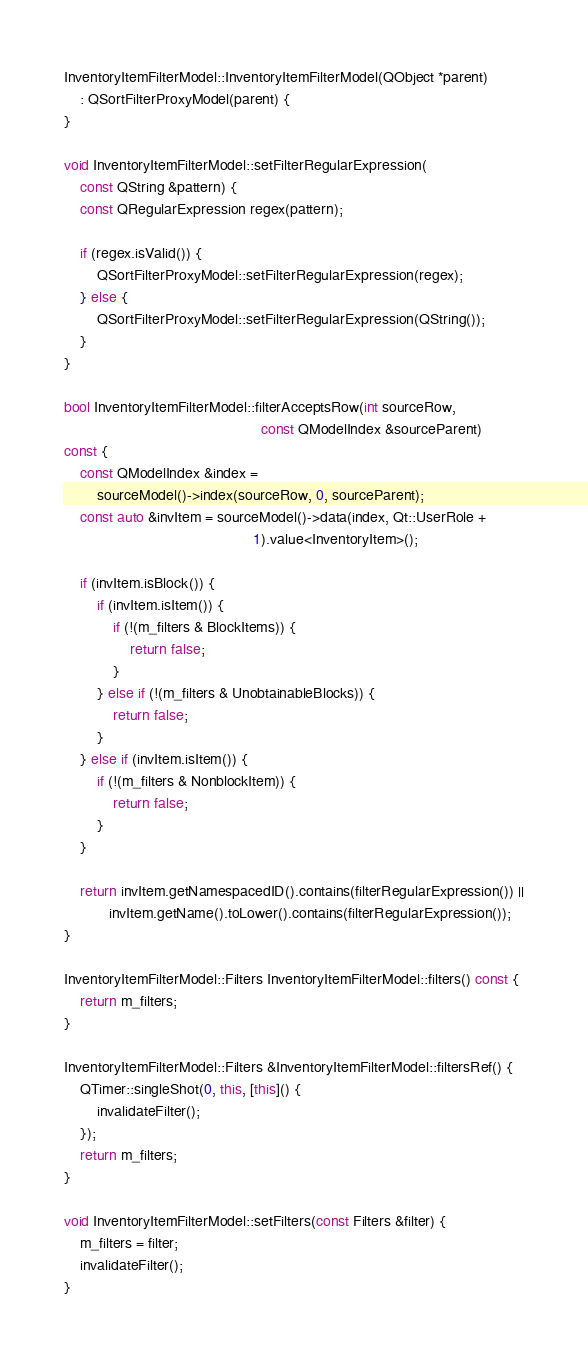Convert code to text. <code><loc_0><loc_0><loc_500><loc_500><_C++_>
InventoryItemFilterModel::InventoryItemFilterModel(QObject *parent)
    : QSortFilterProxyModel(parent) {
}

void InventoryItemFilterModel::setFilterRegularExpression(
    const QString &pattern) {
    const QRegularExpression regex(pattern);

    if (regex.isValid()) {
        QSortFilterProxyModel::setFilterRegularExpression(regex);
    } else {
        QSortFilterProxyModel::setFilterRegularExpression(QString());
    }
}

bool InventoryItemFilterModel::filterAcceptsRow(int sourceRow,
                                                const QModelIndex &sourceParent)
const {
    const QModelIndex &index =
        sourceModel()->index(sourceRow, 0, sourceParent);
    const auto &invItem = sourceModel()->data(index, Qt::UserRole +
                                              1).value<InventoryItem>();

    if (invItem.isBlock()) {
        if (invItem.isItem()) {
            if (!(m_filters & BlockItems)) {
                return false;
            }
        } else if (!(m_filters & UnobtainableBlocks)) {
            return false;
        }
    } else if (invItem.isItem()) {
        if (!(m_filters & NonblockItem)) {
            return false;
        }
    }

    return invItem.getNamespacedID().contains(filterRegularExpression()) ||
           invItem.getName().toLower().contains(filterRegularExpression());
}

InventoryItemFilterModel::Filters InventoryItemFilterModel::filters() const {
    return m_filters;
}

InventoryItemFilterModel::Filters &InventoryItemFilterModel::filtersRef() {
    QTimer::singleShot(0, this, [this]() {
        invalidateFilter();
    });
    return m_filters;
}

void InventoryItemFilterModel::setFilters(const Filters &filter) {
    m_filters = filter;
    invalidateFilter();
}
</code> 